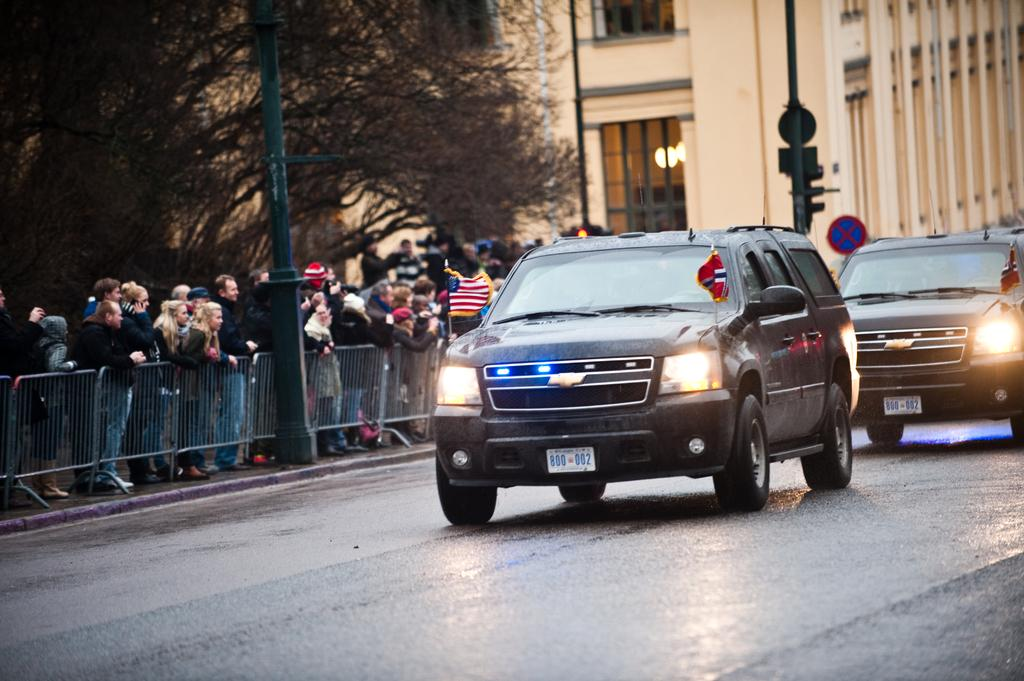What is happening on the road in the image? Vehicles are moving on the road in the image. What can be seen near the road in the image? There is fencing visible in the image, and people are standing near the fencing. What are the people doing near the fencing? The people are watching the vehicles. What can be seen in the background of the image? There are trees and buildings visible in the background of the image. Can you tell me how many monkeys are sitting on the fence in the image? There are no monkeys present in the image; it features people standing near the fencing and watching vehicles. What type of squirrel can be seen running along the fence in the image? There is no squirrel present in the image; it only features people standing near the fencing and watching vehicles. 